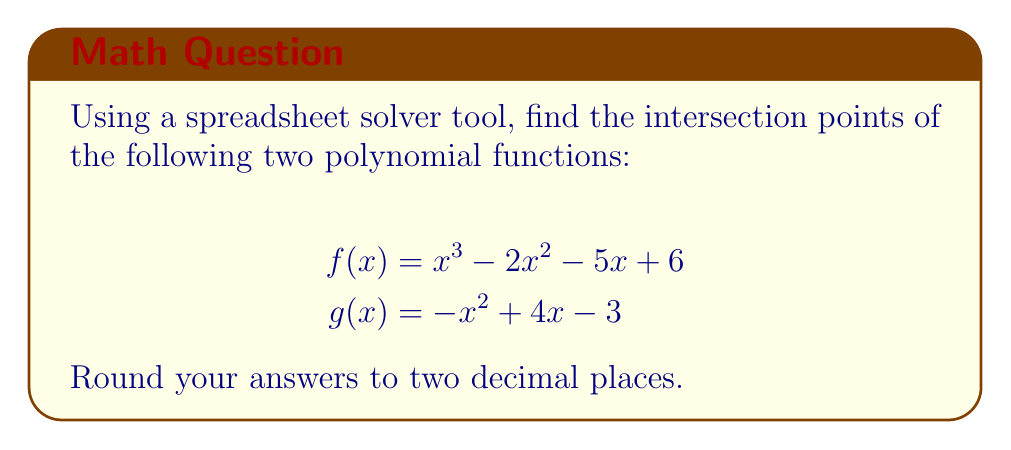Could you help me with this problem? To find the intersection points of these two polynomial functions using a spreadsheet solver tool, follow these steps:

1. Set up your spreadsheet with columns for x, f(x), and g(x).

2. In the f(x) column, enter the formula for $f(x) = x^3 - 2x^2 - 5x + 6$
   For example, in cell B2: =A2^3 - 2*A2^2 - 5*A2 + 6

3. In the g(x) column, enter the formula for $g(x) = -x^2 + 4x - 3$
   For example, in cell C2: =-A2^2 + 4*A2 - 3

4. Create a fourth column for the difference: f(x) - g(x)
   In cell D2: =B2 - C2

5. Use the solver tool to find the roots of this difference function:
   - Set the objective to the difference column (D2)
   - Set the variable cell to the x column (A2)
   - Set the constraint to D2 = 0

6. Run the solver multiple times with different initial values for x to find all intersection points.

7. The solver should converge to three solutions:
   x ≈ -1.61, x ≈ 1.00, and x ≈ 3.61

8. Verify these solutions by plugging them back into both original functions.

9. Round the x-values to two decimal places: -1.61, 1.00, and 3.61

The y-coordinates can be found by evaluating either f(x) or g(x) at these x-values:

For x = -1.61: f(-1.61) ≈ g(-1.61) ≈ -0.59
For x = 1.00: f(1.00) = g(1.00) = 0
For x = 3.61: f(3.61) ≈ g(3.61) ≈ 5.59

Therefore, the intersection points are approximately (-1.61, -0.59), (1.00, 0.00), and (3.61, 5.59).
Answer: (-1.61, -0.59), (1.00, 0.00), (3.61, 5.59) 